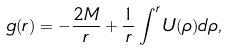<formula> <loc_0><loc_0><loc_500><loc_500>g ( r ) = - \frac { 2 M } { r } + \frac { 1 } { r } \int ^ { r } U ( \rho ) d \rho ,</formula> 